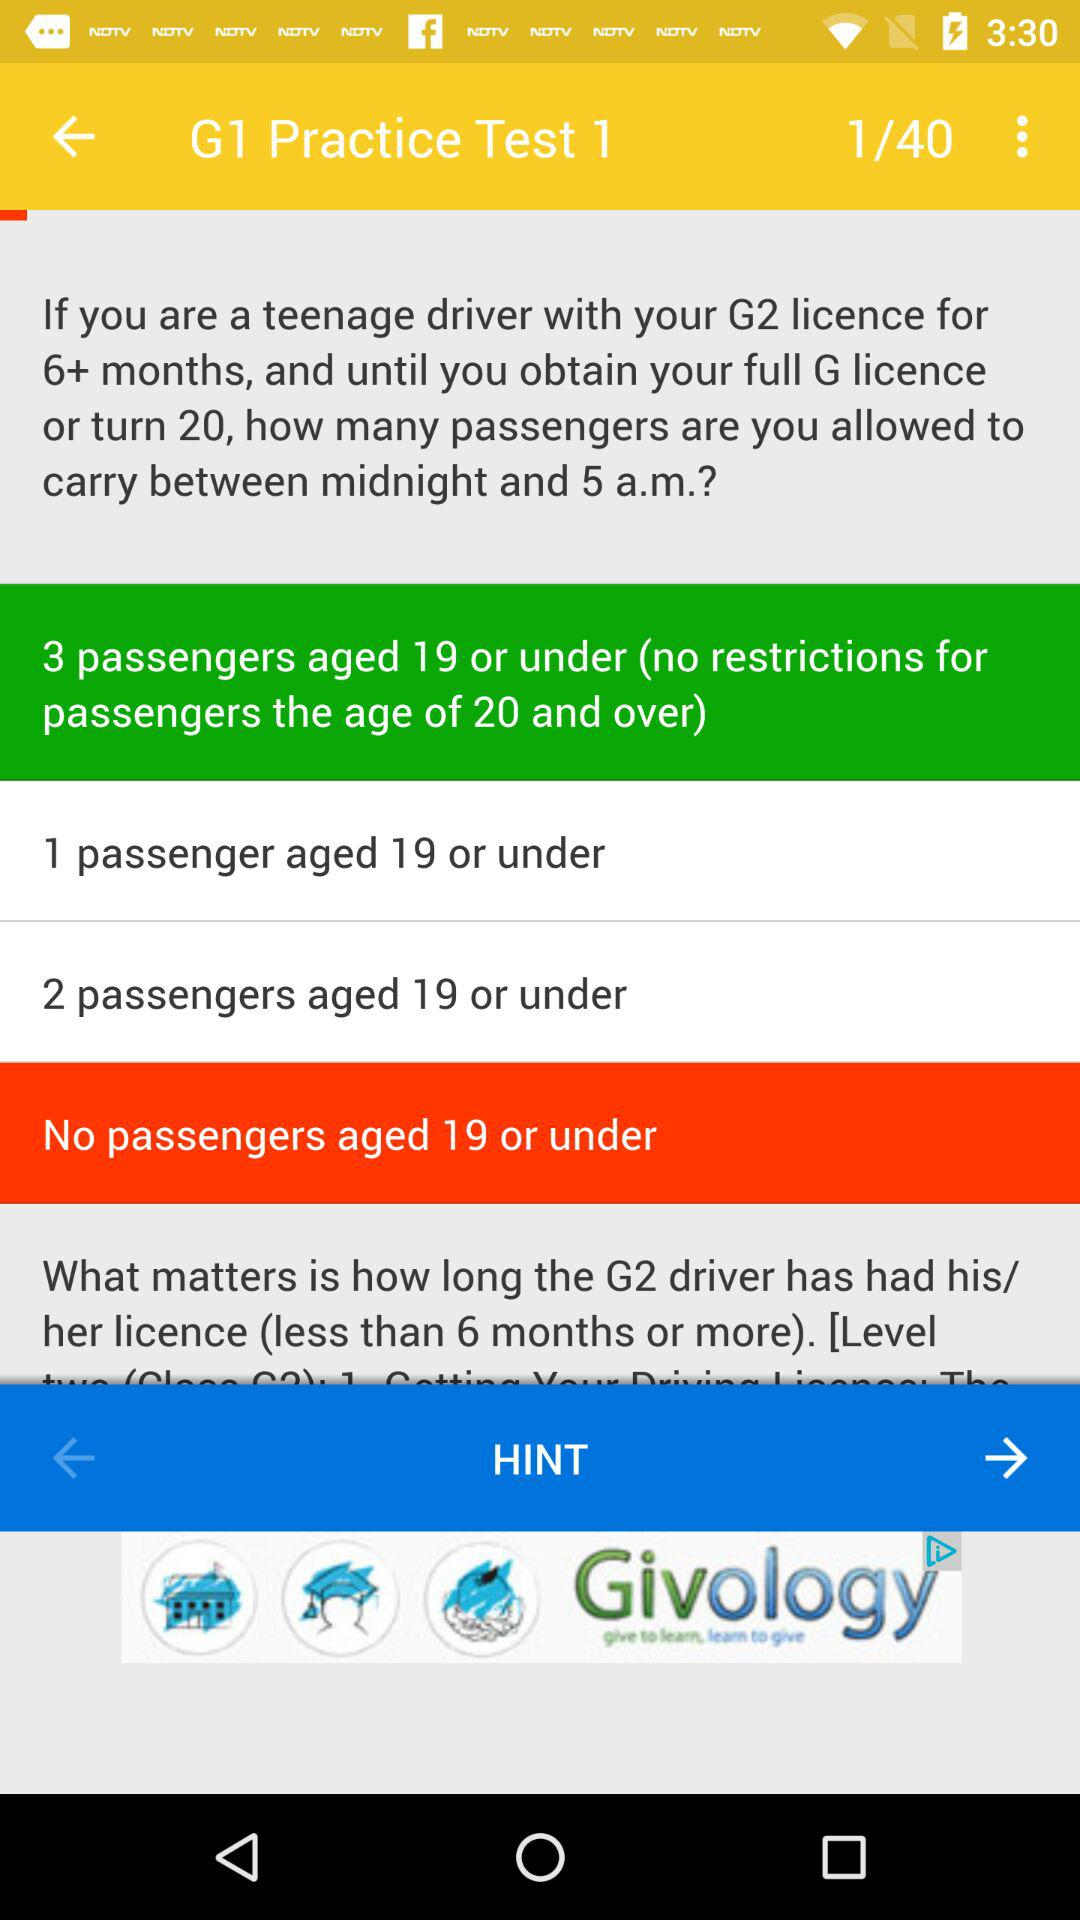Currently, we are on what test number? You are on test number 1. 